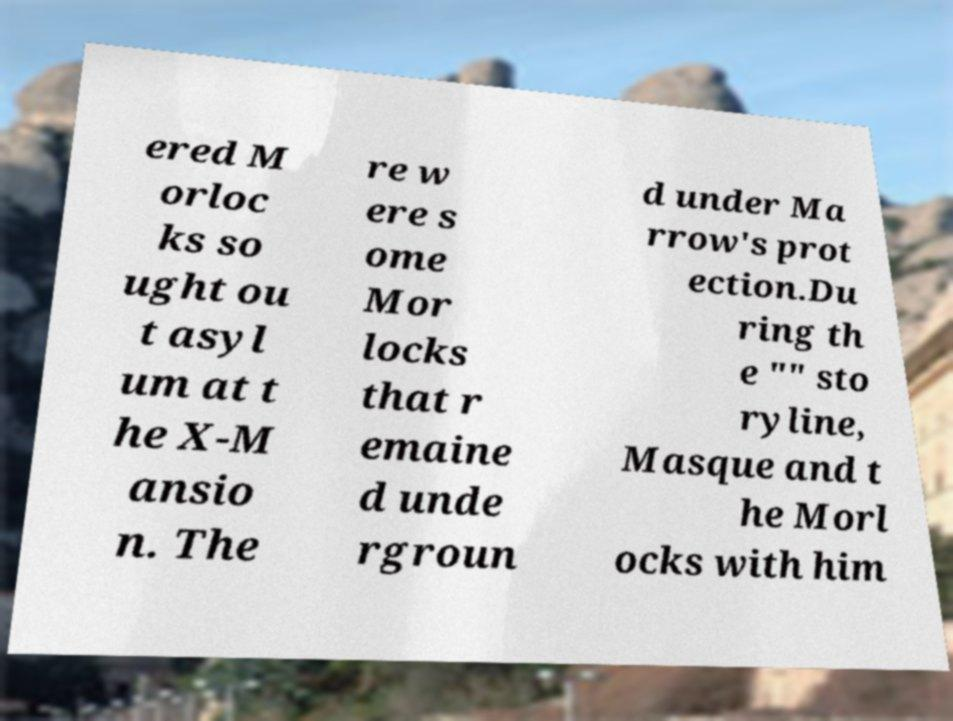Please identify and transcribe the text found in this image. ered M orloc ks so ught ou t asyl um at t he X-M ansio n. The re w ere s ome Mor locks that r emaine d unde rgroun d under Ma rrow's prot ection.Du ring th e "" sto ryline, Masque and t he Morl ocks with him 